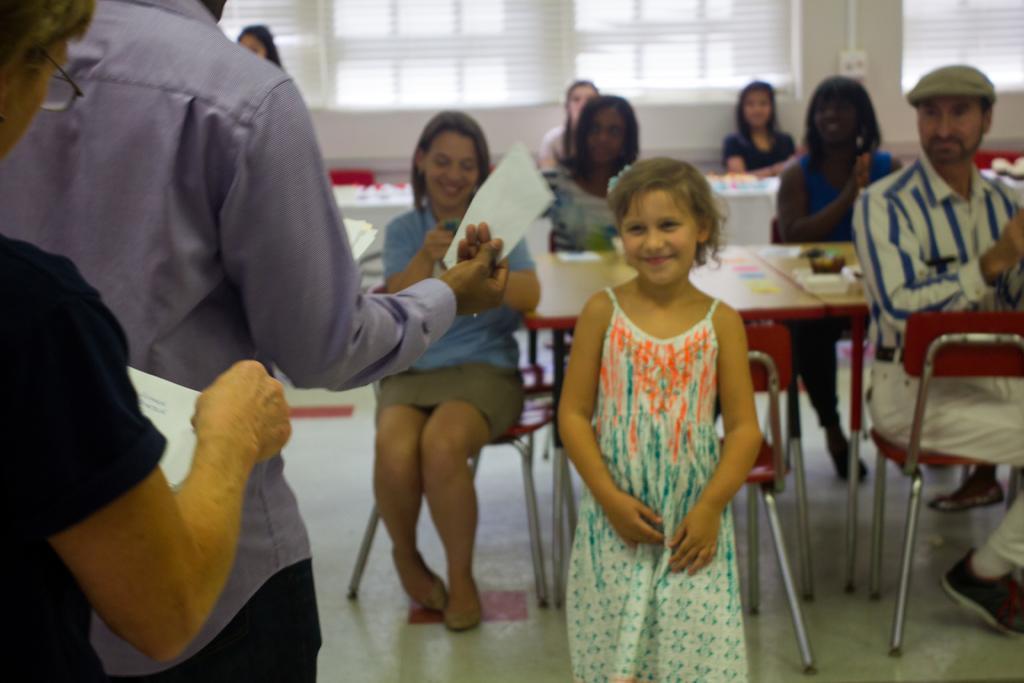Can you describe this image briefly? In this image I can see few people are sitting on the chairs and few people are standing and holding papers. I can see few objects on the tables. Back I can see windows,white curtains and white wall. 